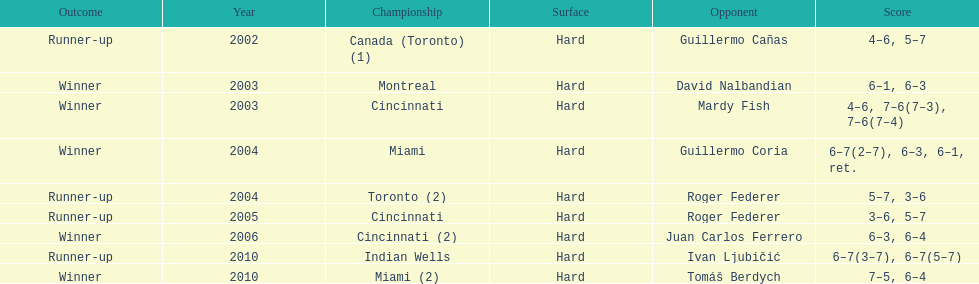Can you provide the count of championships that happened in either toronto or montreal? 3. 